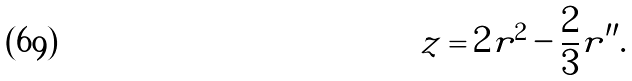Convert formula to latex. <formula><loc_0><loc_0><loc_500><loc_500>z = 2 r ^ { 2 } - \frac { 2 } { 3 } r ^ { \prime \prime } .</formula> 